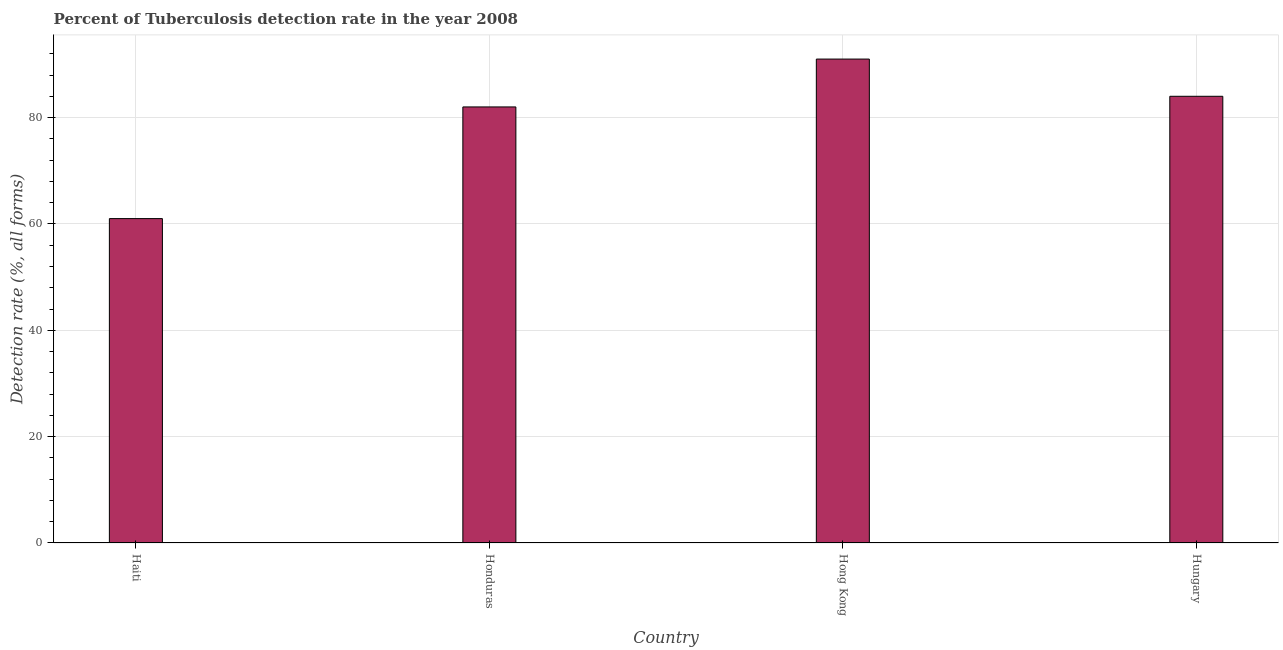Does the graph contain any zero values?
Offer a terse response. No. Does the graph contain grids?
Your answer should be compact. Yes. What is the title of the graph?
Provide a succinct answer. Percent of Tuberculosis detection rate in the year 2008. What is the label or title of the X-axis?
Ensure brevity in your answer.  Country. What is the label or title of the Y-axis?
Give a very brief answer. Detection rate (%, all forms). Across all countries, what is the maximum detection rate of tuberculosis?
Your answer should be very brief. 91. Across all countries, what is the minimum detection rate of tuberculosis?
Offer a very short reply. 61. In which country was the detection rate of tuberculosis maximum?
Keep it short and to the point. Hong Kong. In which country was the detection rate of tuberculosis minimum?
Offer a very short reply. Haiti. What is the sum of the detection rate of tuberculosis?
Ensure brevity in your answer.  318. What is the average detection rate of tuberculosis per country?
Make the answer very short. 79. What is the median detection rate of tuberculosis?
Offer a very short reply. 83. In how many countries, is the detection rate of tuberculosis greater than 48 %?
Give a very brief answer. 4. Is the detection rate of tuberculosis in Haiti less than that in Honduras?
Keep it short and to the point. Yes. Is the difference between the detection rate of tuberculosis in Haiti and Hong Kong greater than the difference between any two countries?
Offer a very short reply. Yes. What is the difference between the highest and the second highest detection rate of tuberculosis?
Offer a very short reply. 7. Is the sum of the detection rate of tuberculosis in Haiti and Hungary greater than the maximum detection rate of tuberculosis across all countries?
Your answer should be compact. Yes. What is the difference between two consecutive major ticks on the Y-axis?
Your response must be concise. 20. Are the values on the major ticks of Y-axis written in scientific E-notation?
Your answer should be compact. No. What is the Detection rate (%, all forms) in Hong Kong?
Ensure brevity in your answer.  91. What is the difference between the Detection rate (%, all forms) in Haiti and Honduras?
Your response must be concise. -21. What is the difference between the Detection rate (%, all forms) in Honduras and Hong Kong?
Keep it short and to the point. -9. What is the difference between the Detection rate (%, all forms) in Honduras and Hungary?
Give a very brief answer. -2. What is the difference between the Detection rate (%, all forms) in Hong Kong and Hungary?
Offer a very short reply. 7. What is the ratio of the Detection rate (%, all forms) in Haiti to that in Honduras?
Provide a succinct answer. 0.74. What is the ratio of the Detection rate (%, all forms) in Haiti to that in Hong Kong?
Offer a terse response. 0.67. What is the ratio of the Detection rate (%, all forms) in Haiti to that in Hungary?
Provide a short and direct response. 0.73. What is the ratio of the Detection rate (%, all forms) in Honduras to that in Hong Kong?
Provide a succinct answer. 0.9. What is the ratio of the Detection rate (%, all forms) in Honduras to that in Hungary?
Your answer should be compact. 0.98. What is the ratio of the Detection rate (%, all forms) in Hong Kong to that in Hungary?
Ensure brevity in your answer.  1.08. 